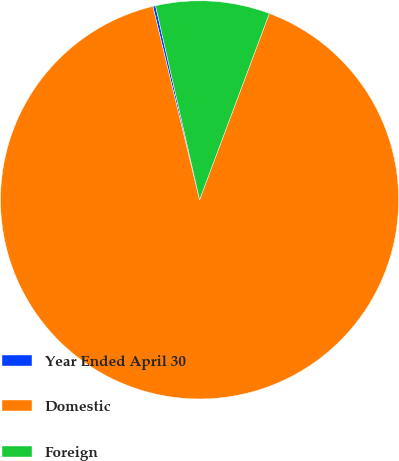Convert chart. <chart><loc_0><loc_0><loc_500><loc_500><pie_chart><fcel>Year Ended April 30<fcel>Domestic<fcel>Foreign<nl><fcel>0.22%<fcel>90.52%<fcel>9.25%<nl></chart> 